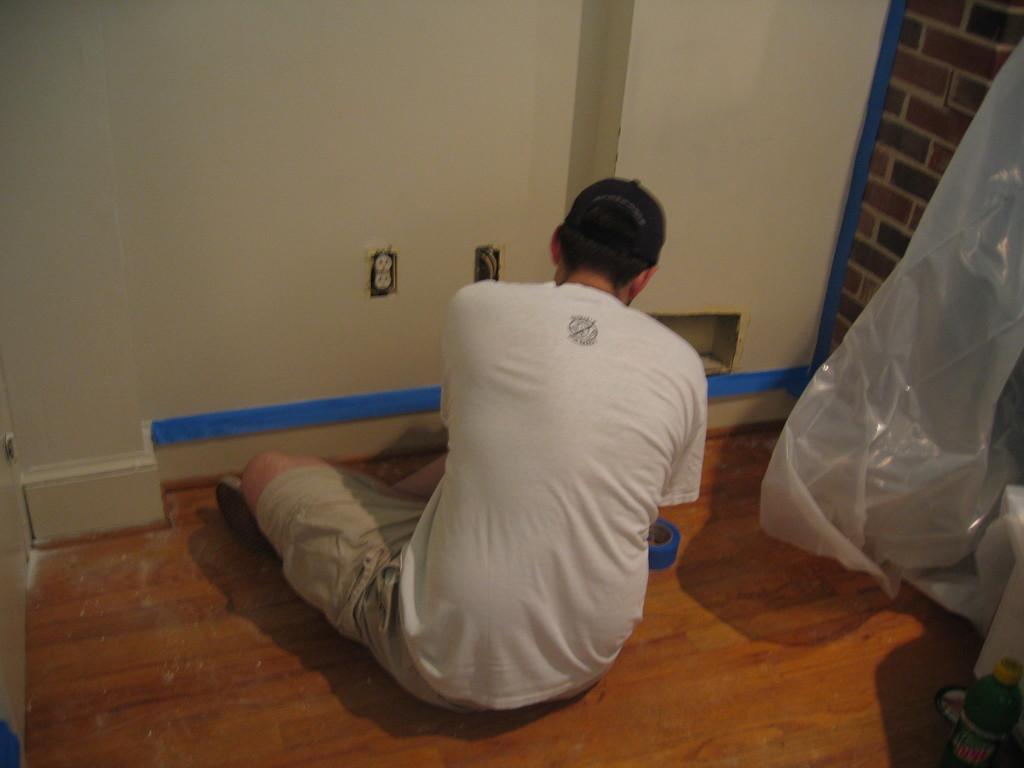How would you summarize this image in a sentence or two? As we can see in the image there is a wall, cover and a person wearing white color t shirt. 